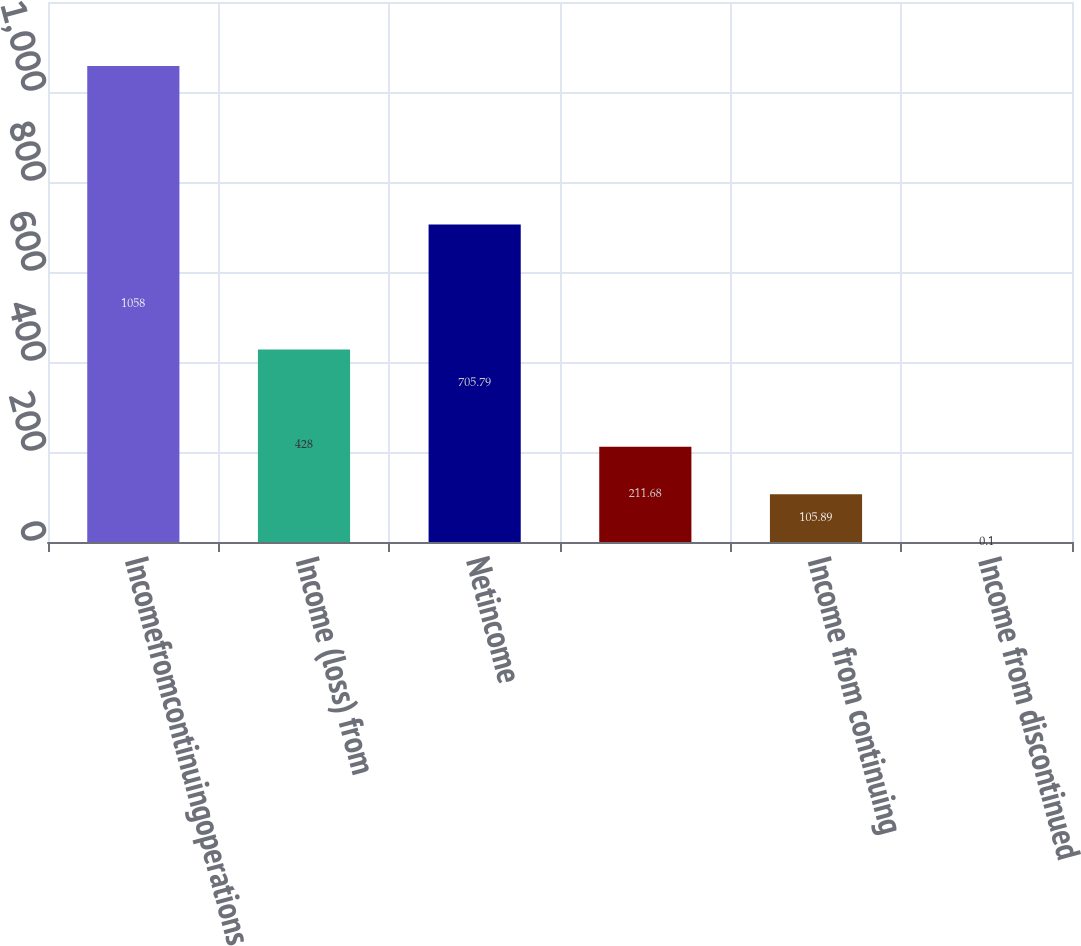Convert chart to OTSL. <chart><loc_0><loc_0><loc_500><loc_500><bar_chart><fcel>Incomefromcontinuingoperations<fcel>Income (loss) from<fcel>Netincome<fcel>Unnamed: 3<fcel>Income from continuing<fcel>Income from discontinued<nl><fcel>1058<fcel>428<fcel>705.79<fcel>211.68<fcel>105.89<fcel>0.1<nl></chart> 